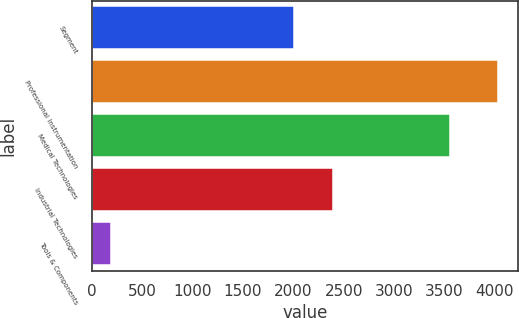<chart> <loc_0><loc_0><loc_500><loc_500><bar_chart><fcel>Segment<fcel>Professional Instrumentation<fcel>Medical Technologies<fcel>Industrial Technologies<fcel>Tools & Components<nl><fcel>2009<fcel>4028<fcel>3555<fcel>2392.4<fcel>194<nl></chart> 